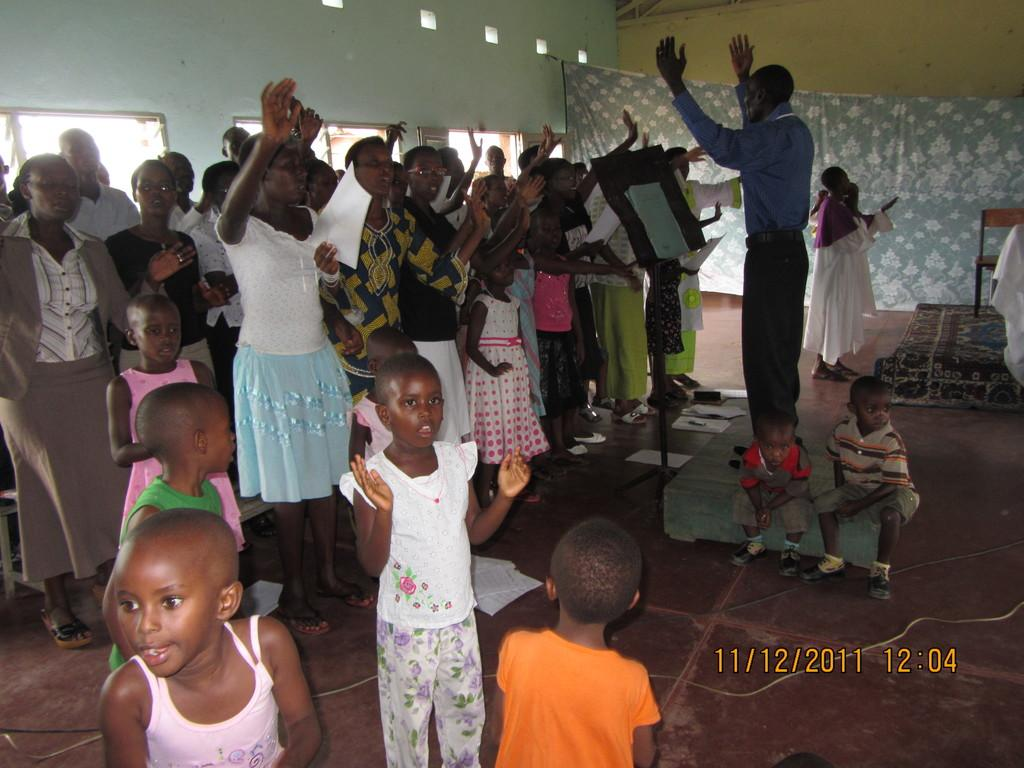What is the main subject of the image? The main subject of the image is a group of people standing. Are there any children in the image? Yes, two kids are sitting in the image. What can be seen in the background of the image? There is a wall and cloth in the background of the image. Is there any indication of the image being a digital copy? Yes, the image has a watermark. What type of sink can be seen in the image? There is no sink present in the image. How does the acoustics of the room affect the conversation in the image? The image does not provide any information about the acoustics of the room, so it cannot be determined how they might affect the conversation. 